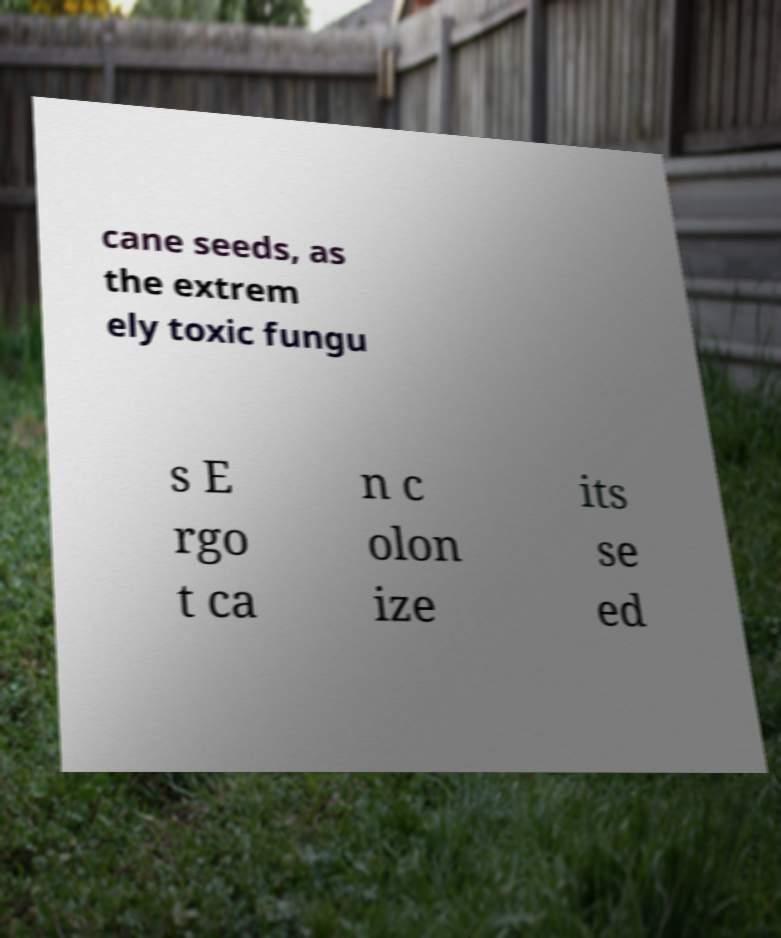Can you read and provide the text displayed in the image?This photo seems to have some interesting text. Can you extract and type it out for me? cane seeds, as the extrem ely toxic fungu s E rgo t ca n c olon ize its se ed 